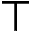Convert formula to latex. <formula><loc_0><loc_0><loc_500><loc_500>\top</formula> 